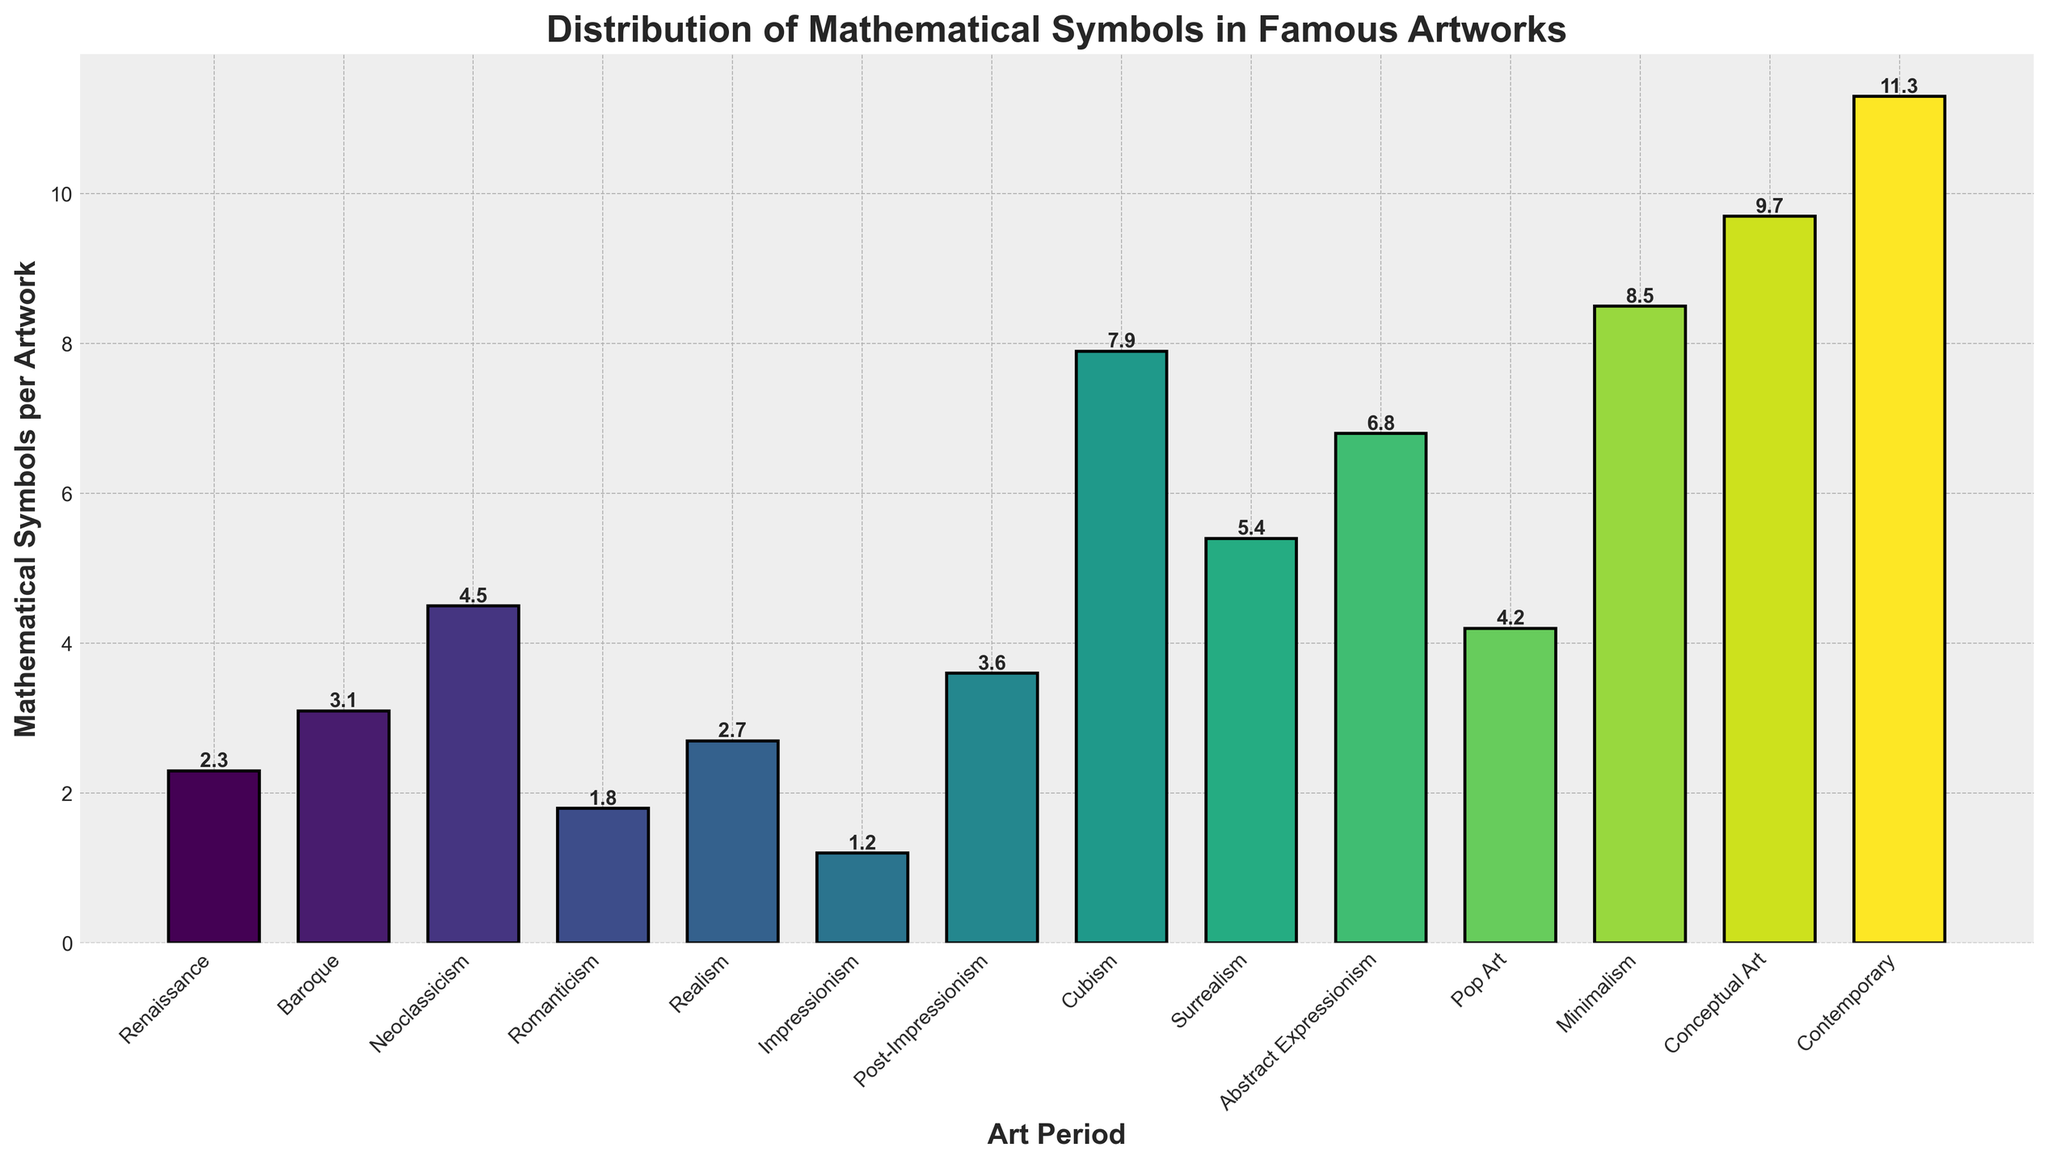What's the average number of mathematical symbols per artwork observed across all periods? To find the average number of mathematical symbols per artwork, sum the values of all periods and divide by the number of periods. Sum = 2.3 + 3.1 + 4.5 + 1.8 + 2.7 + 1.2 + 3.6 + 7.9 + 5.4 + 6.8 + 4.2 + 8.5 + 9.7 + 11.3 = 72.0. There are 14 periods, so the average is 72.0 / 14 = 5.1
Answer: 5.1 Which art period has the highest number of mathematical symbols per artwork? The bar representing Contemporary period is the tallest, indicating it has the highest number of mathematical symbols per artwork, which is 11.3 as shown above the bar.
Answer: Contemporary By how much does the number of mathematical symbols per artwork in Minimalism exceed that in Impressionism? The number of symbols per artwork for Minimalism is 8.5 and for Impressionism, it's 1.2. The difference is 8.5 - 1.2 = 7.3.
Answer: 7.3 Which period shows a greater number of mathematical symbols per artwork: Baroque or Realism? Compare the heights of the bars for Baroque and Realism. Baroque is 3.1 while Realism is 2.7.
Answer: Baroque What's the total number of mathematical symbols per artwork for Neoclassicism and Surrealism combined? The value for Neoclassicism is 4.5 and for Surrealism, it's 5.4. The combined total is 4.5 + 5.4 = 9.9
Answer: 9.9 Which art period experienced the largest increase in the number of mathematical symbols compared to the Renaissance period? Subtract the number of symbols in the Renaissance period (2.3) from each subsequent period and identify the largest difference. The largest difference is for Contemporary: 11.3 - 2.3 = 9.0
Answer: Contemporary How many more symbols per artwork does Cubism have compared to Romanticism? The value for Cubism is 7.9 and for Romanticism, it's 1.8. The difference is 7.9 - 1.8 = 6.1
Answer: 6.1 Based on the bar colors, which art period corresponds to the darkest shade of colors used in the figure? The figure uses progressively varying shades from light to dark. The darkest shade represents Contemporary, as it is at the end of the color gradient.
Answer: Contemporary What's the difference between the period with the second highest number of symbols and the one with the lowest? Minimalism is second highest at 9.7 and Impressionism is the lowest at 1.2. The difference is 9.7 - 1.2 = 8.5
Answer: 8.5 Which periods have a number of mathematical symbols per artwork greater than 5? From the bar chart, periods with values greater than 5 are Cubism (7.9), Surrealism (5.4), Abstract Expressionism (6.8), Minimalism (8.5), Conceptual Art (9.7), and Contemporary (11.3).
Answer: Cubism, Surrealism, Abstract Expressionism, Minimalism, Conceptual Art, Contemporary 